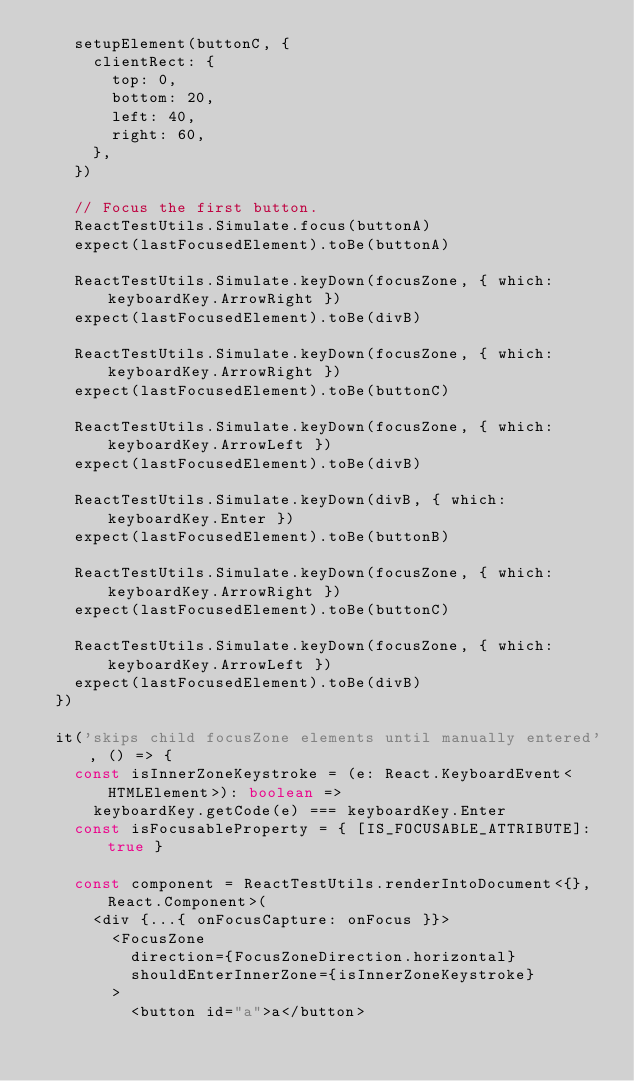Convert code to text. <code><loc_0><loc_0><loc_500><loc_500><_TypeScript_>    setupElement(buttonC, {
      clientRect: {
        top: 0,
        bottom: 20,
        left: 40,
        right: 60,
      },
    })

    // Focus the first button.
    ReactTestUtils.Simulate.focus(buttonA)
    expect(lastFocusedElement).toBe(buttonA)

    ReactTestUtils.Simulate.keyDown(focusZone, { which: keyboardKey.ArrowRight })
    expect(lastFocusedElement).toBe(divB)

    ReactTestUtils.Simulate.keyDown(focusZone, { which: keyboardKey.ArrowRight })
    expect(lastFocusedElement).toBe(buttonC)

    ReactTestUtils.Simulate.keyDown(focusZone, { which: keyboardKey.ArrowLeft })
    expect(lastFocusedElement).toBe(divB)

    ReactTestUtils.Simulate.keyDown(divB, { which: keyboardKey.Enter })
    expect(lastFocusedElement).toBe(buttonB)

    ReactTestUtils.Simulate.keyDown(focusZone, { which: keyboardKey.ArrowRight })
    expect(lastFocusedElement).toBe(buttonC)

    ReactTestUtils.Simulate.keyDown(focusZone, { which: keyboardKey.ArrowLeft })
    expect(lastFocusedElement).toBe(divB)
  })

  it('skips child focusZone elements until manually entered', () => {
    const isInnerZoneKeystroke = (e: React.KeyboardEvent<HTMLElement>): boolean =>
      keyboardKey.getCode(e) === keyboardKey.Enter
    const isFocusableProperty = { [IS_FOCUSABLE_ATTRIBUTE]: true }

    const component = ReactTestUtils.renderIntoDocument<{}, React.Component>(
      <div {...{ onFocusCapture: onFocus }}>
        <FocusZone
          direction={FocusZoneDirection.horizontal}
          shouldEnterInnerZone={isInnerZoneKeystroke}
        >
          <button id="a">a</button></code> 